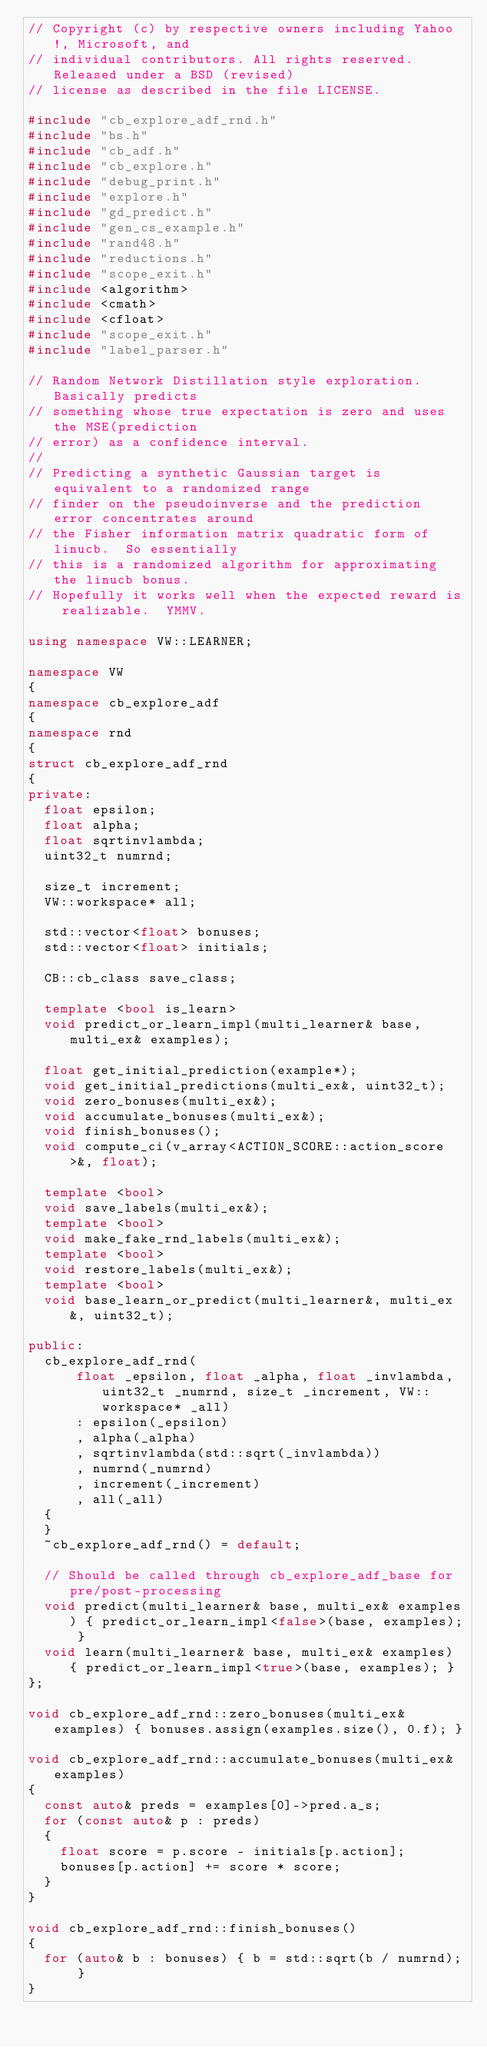<code> <loc_0><loc_0><loc_500><loc_500><_C++_>// Copyright (c) by respective owners including Yahoo!, Microsoft, and
// individual contributors. All rights reserved. Released under a BSD (revised)
// license as described in the file LICENSE.

#include "cb_explore_adf_rnd.h"
#include "bs.h"
#include "cb_adf.h"
#include "cb_explore.h"
#include "debug_print.h"
#include "explore.h"
#include "gd_predict.h"
#include "gen_cs_example.h"
#include "rand48.h"
#include "reductions.h"
#include "scope_exit.h"
#include <algorithm>
#include <cmath>
#include <cfloat>
#include "scope_exit.h"
#include "label_parser.h"

// Random Network Distillation style exploration.  Basically predicts
// something whose true expectation is zero and uses the MSE(prediction
// error) as a confidence interval.
//
// Predicting a synthetic Gaussian target is equivalent to a randomized range
// finder on the pseudoinverse and the prediction error concentrates around
// the Fisher information matrix quadratic form of linucb.  So essentially
// this is a randomized algorithm for approximating the linucb bonus.
// Hopefully it works well when the expected reward is realizable.  YMMV.

using namespace VW::LEARNER;

namespace VW
{
namespace cb_explore_adf
{
namespace rnd
{
struct cb_explore_adf_rnd
{
private:
  float epsilon;
  float alpha;
  float sqrtinvlambda;
  uint32_t numrnd;

  size_t increment;
  VW::workspace* all;

  std::vector<float> bonuses;
  std::vector<float> initials;

  CB::cb_class save_class;

  template <bool is_learn>
  void predict_or_learn_impl(multi_learner& base, multi_ex& examples);

  float get_initial_prediction(example*);
  void get_initial_predictions(multi_ex&, uint32_t);
  void zero_bonuses(multi_ex&);
  void accumulate_bonuses(multi_ex&);
  void finish_bonuses();
  void compute_ci(v_array<ACTION_SCORE::action_score>&, float);

  template <bool>
  void save_labels(multi_ex&);
  template <bool>
  void make_fake_rnd_labels(multi_ex&);
  template <bool>
  void restore_labels(multi_ex&);
  template <bool>
  void base_learn_or_predict(multi_learner&, multi_ex&, uint32_t);

public:
  cb_explore_adf_rnd(
      float _epsilon, float _alpha, float _invlambda, uint32_t _numrnd, size_t _increment, VW::workspace* _all)
      : epsilon(_epsilon)
      , alpha(_alpha)
      , sqrtinvlambda(std::sqrt(_invlambda))
      , numrnd(_numrnd)
      , increment(_increment)
      , all(_all)
  {
  }
  ~cb_explore_adf_rnd() = default;

  // Should be called through cb_explore_adf_base for pre/post-processing
  void predict(multi_learner& base, multi_ex& examples) { predict_or_learn_impl<false>(base, examples); }
  void learn(multi_learner& base, multi_ex& examples) { predict_or_learn_impl<true>(base, examples); }
};

void cb_explore_adf_rnd::zero_bonuses(multi_ex& examples) { bonuses.assign(examples.size(), 0.f); }

void cb_explore_adf_rnd::accumulate_bonuses(multi_ex& examples)
{
  const auto& preds = examples[0]->pred.a_s;
  for (const auto& p : preds)
  {
    float score = p.score - initials[p.action];
    bonuses[p.action] += score * score;
  }
}

void cb_explore_adf_rnd::finish_bonuses()
{
  for (auto& b : bonuses) { b = std::sqrt(b / numrnd); }
}
</code> 